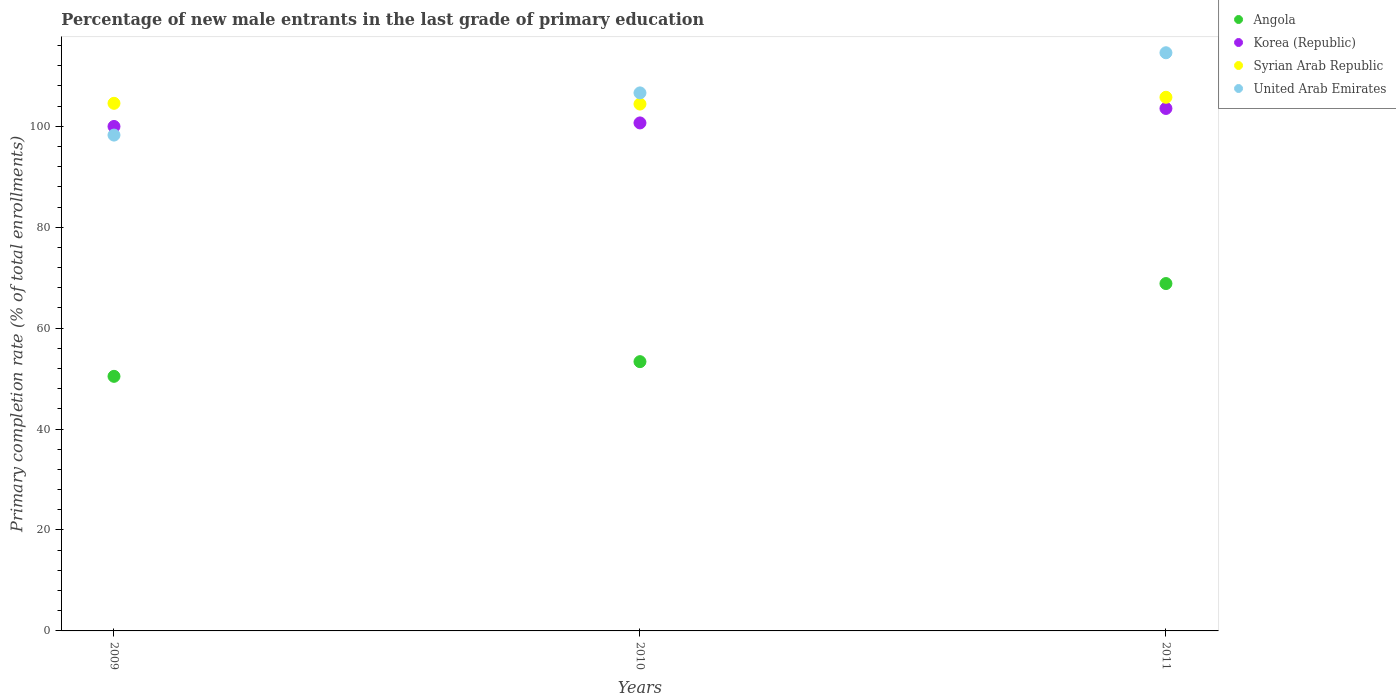How many different coloured dotlines are there?
Provide a succinct answer. 4. Is the number of dotlines equal to the number of legend labels?
Your answer should be very brief. Yes. What is the percentage of new male entrants in United Arab Emirates in 2009?
Your answer should be very brief. 98.25. Across all years, what is the maximum percentage of new male entrants in Korea (Republic)?
Your response must be concise. 103.53. Across all years, what is the minimum percentage of new male entrants in Korea (Republic)?
Provide a succinct answer. 99.96. In which year was the percentage of new male entrants in Angola maximum?
Give a very brief answer. 2011. What is the total percentage of new male entrants in United Arab Emirates in the graph?
Keep it short and to the point. 319.42. What is the difference between the percentage of new male entrants in Korea (Republic) in 2010 and that in 2011?
Keep it short and to the point. -2.87. What is the difference between the percentage of new male entrants in Korea (Republic) in 2010 and the percentage of new male entrants in United Arab Emirates in 2009?
Provide a short and direct response. 2.41. What is the average percentage of new male entrants in United Arab Emirates per year?
Your answer should be compact. 106.47. In the year 2011, what is the difference between the percentage of new male entrants in Korea (Republic) and percentage of new male entrants in Syrian Arab Republic?
Your response must be concise. -2.22. In how many years, is the percentage of new male entrants in Korea (Republic) greater than 100 %?
Offer a very short reply. 2. What is the ratio of the percentage of new male entrants in United Arab Emirates in 2009 to that in 2010?
Keep it short and to the point. 0.92. Is the percentage of new male entrants in Angola in 2010 less than that in 2011?
Your answer should be very brief. Yes. Is the difference between the percentage of new male entrants in Korea (Republic) in 2009 and 2010 greater than the difference between the percentage of new male entrants in Syrian Arab Republic in 2009 and 2010?
Make the answer very short. No. What is the difference between the highest and the second highest percentage of new male entrants in United Arab Emirates?
Ensure brevity in your answer.  7.95. What is the difference between the highest and the lowest percentage of new male entrants in Syrian Arab Republic?
Your answer should be very brief. 1.34. Is the sum of the percentage of new male entrants in Korea (Republic) in 2009 and 2010 greater than the maximum percentage of new male entrants in United Arab Emirates across all years?
Offer a very short reply. Yes. Does the percentage of new male entrants in Syrian Arab Republic monotonically increase over the years?
Offer a very short reply. No. Is the percentage of new male entrants in Angola strictly greater than the percentage of new male entrants in Syrian Arab Republic over the years?
Make the answer very short. No. How many dotlines are there?
Your response must be concise. 4. How many years are there in the graph?
Your answer should be very brief. 3. What is the difference between two consecutive major ticks on the Y-axis?
Ensure brevity in your answer.  20. Are the values on the major ticks of Y-axis written in scientific E-notation?
Make the answer very short. No. How are the legend labels stacked?
Offer a very short reply. Vertical. What is the title of the graph?
Keep it short and to the point. Percentage of new male entrants in the last grade of primary education. Does "United States" appear as one of the legend labels in the graph?
Your answer should be very brief. No. What is the label or title of the Y-axis?
Ensure brevity in your answer.  Primary completion rate (% of total enrollments). What is the Primary completion rate (% of total enrollments) of Angola in 2009?
Ensure brevity in your answer.  50.45. What is the Primary completion rate (% of total enrollments) in Korea (Republic) in 2009?
Your answer should be compact. 99.96. What is the Primary completion rate (% of total enrollments) of Syrian Arab Republic in 2009?
Make the answer very short. 104.54. What is the Primary completion rate (% of total enrollments) of United Arab Emirates in 2009?
Provide a succinct answer. 98.25. What is the Primary completion rate (% of total enrollments) in Angola in 2010?
Offer a very short reply. 53.36. What is the Primary completion rate (% of total enrollments) in Korea (Republic) in 2010?
Provide a short and direct response. 100.66. What is the Primary completion rate (% of total enrollments) in Syrian Arab Republic in 2010?
Keep it short and to the point. 104.4. What is the Primary completion rate (% of total enrollments) in United Arab Emirates in 2010?
Provide a short and direct response. 106.61. What is the Primary completion rate (% of total enrollments) of Angola in 2011?
Ensure brevity in your answer.  68.83. What is the Primary completion rate (% of total enrollments) in Korea (Republic) in 2011?
Make the answer very short. 103.53. What is the Primary completion rate (% of total enrollments) in Syrian Arab Republic in 2011?
Your answer should be compact. 105.74. What is the Primary completion rate (% of total enrollments) of United Arab Emirates in 2011?
Ensure brevity in your answer.  114.56. Across all years, what is the maximum Primary completion rate (% of total enrollments) in Angola?
Your answer should be very brief. 68.83. Across all years, what is the maximum Primary completion rate (% of total enrollments) in Korea (Republic)?
Offer a terse response. 103.53. Across all years, what is the maximum Primary completion rate (% of total enrollments) in Syrian Arab Republic?
Make the answer very short. 105.74. Across all years, what is the maximum Primary completion rate (% of total enrollments) of United Arab Emirates?
Make the answer very short. 114.56. Across all years, what is the minimum Primary completion rate (% of total enrollments) in Angola?
Your answer should be compact. 50.45. Across all years, what is the minimum Primary completion rate (% of total enrollments) in Korea (Republic)?
Your answer should be very brief. 99.96. Across all years, what is the minimum Primary completion rate (% of total enrollments) in Syrian Arab Republic?
Your answer should be very brief. 104.4. Across all years, what is the minimum Primary completion rate (% of total enrollments) in United Arab Emirates?
Make the answer very short. 98.25. What is the total Primary completion rate (% of total enrollments) in Angola in the graph?
Offer a very short reply. 172.63. What is the total Primary completion rate (% of total enrollments) in Korea (Republic) in the graph?
Your answer should be very brief. 304.14. What is the total Primary completion rate (% of total enrollments) in Syrian Arab Republic in the graph?
Your answer should be compact. 314.69. What is the total Primary completion rate (% of total enrollments) of United Arab Emirates in the graph?
Your answer should be very brief. 319.42. What is the difference between the Primary completion rate (% of total enrollments) of Angola in 2009 and that in 2010?
Provide a succinct answer. -2.91. What is the difference between the Primary completion rate (% of total enrollments) of Korea (Republic) in 2009 and that in 2010?
Provide a succinct answer. -0.7. What is the difference between the Primary completion rate (% of total enrollments) in Syrian Arab Republic in 2009 and that in 2010?
Make the answer very short. 0.14. What is the difference between the Primary completion rate (% of total enrollments) of United Arab Emirates in 2009 and that in 2010?
Your answer should be very brief. -8.36. What is the difference between the Primary completion rate (% of total enrollments) in Angola in 2009 and that in 2011?
Your answer should be compact. -18.39. What is the difference between the Primary completion rate (% of total enrollments) in Korea (Republic) in 2009 and that in 2011?
Your answer should be compact. -3.57. What is the difference between the Primary completion rate (% of total enrollments) of Syrian Arab Republic in 2009 and that in 2011?
Your answer should be compact. -1.2. What is the difference between the Primary completion rate (% of total enrollments) of United Arab Emirates in 2009 and that in 2011?
Ensure brevity in your answer.  -16.31. What is the difference between the Primary completion rate (% of total enrollments) of Angola in 2010 and that in 2011?
Ensure brevity in your answer.  -15.48. What is the difference between the Primary completion rate (% of total enrollments) of Korea (Republic) in 2010 and that in 2011?
Ensure brevity in your answer.  -2.87. What is the difference between the Primary completion rate (% of total enrollments) in Syrian Arab Republic in 2010 and that in 2011?
Offer a terse response. -1.34. What is the difference between the Primary completion rate (% of total enrollments) of United Arab Emirates in 2010 and that in 2011?
Offer a very short reply. -7.95. What is the difference between the Primary completion rate (% of total enrollments) in Angola in 2009 and the Primary completion rate (% of total enrollments) in Korea (Republic) in 2010?
Provide a short and direct response. -50.21. What is the difference between the Primary completion rate (% of total enrollments) in Angola in 2009 and the Primary completion rate (% of total enrollments) in Syrian Arab Republic in 2010?
Provide a short and direct response. -53.96. What is the difference between the Primary completion rate (% of total enrollments) of Angola in 2009 and the Primary completion rate (% of total enrollments) of United Arab Emirates in 2010?
Give a very brief answer. -56.16. What is the difference between the Primary completion rate (% of total enrollments) of Korea (Republic) in 2009 and the Primary completion rate (% of total enrollments) of Syrian Arab Republic in 2010?
Keep it short and to the point. -4.44. What is the difference between the Primary completion rate (% of total enrollments) of Korea (Republic) in 2009 and the Primary completion rate (% of total enrollments) of United Arab Emirates in 2010?
Ensure brevity in your answer.  -6.65. What is the difference between the Primary completion rate (% of total enrollments) in Syrian Arab Republic in 2009 and the Primary completion rate (% of total enrollments) in United Arab Emirates in 2010?
Keep it short and to the point. -2.07. What is the difference between the Primary completion rate (% of total enrollments) of Angola in 2009 and the Primary completion rate (% of total enrollments) of Korea (Republic) in 2011?
Your response must be concise. -53.08. What is the difference between the Primary completion rate (% of total enrollments) of Angola in 2009 and the Primary completion rate (% of total enrollments) of Syrian Arab Republic in 2011?
Keep it short and to the point. -55.3. What is the difference between the Primary completion rate (% of total enrollments) in Angola in 2009 and the Primary completion rate (% of total enrollments) in United Arab Emirates in 2011?
Keep it short and to the point. -64.12. What is the difference between the Primary completion rate (% of total enrollments) in Korea (Republic) in 2009 and the Primary completion rate (% of total enrollments) in Syrian Arab Republic in 2011?
Give a very brief answer. -5.78. What is the difference between the Primary completion rate (% of total enrollments) of Korea (Republic) in 2009 and the Primary completion rate (% of total enrollments) of United Arab Emirates in 2011?
Your answer should be compact. -14.61. What is the difference between the Primary completion rate (% of total enrollments) in Syrian Arab Republic in 2009 and the Primary completion rate (% of total enrollments) in United Arab Emirates in 2011?
Provide a succinct answer. -10.02. What is the difference between the Primary completion rate (% of total enrollments) of Angola in 2010 and the Primary completion rate (% of total enrollments) of Korea (Republic) in 2011?
Provide a short and direct response. -50.17. What is the difference between the Primary completion rate (% of total enrollments) of Angola in 2010 and the Primary completion rate (% of total enrollments) of Syrian Arab Republic in 2011?
Offer a terse response. -52.39. What is the difference between the Primary completion rate (% of total enrollments) in Angola in 2010 and the Primary completion rate (% of total enrollments) in United Arab Emirates in 2011?
Provide a short and direct response. -61.21. What is the difference between the Primary completion rate (% of total enrollments) in Korea (Republic) in 2010 and the Primary completion rate (% of total enrollments) in Syrian Arab Republic in 2011?
Your response must be concise. -5.08. What is the difference between the Primary completion rate (% of total enrollments) of Korea (Republic) in 2010 and the Primary completion rate (% of total enrollments) of United Arab Emirates in 2011?
Ensure brevity in your answer.  -13.9. What is the difference between the Primary completion rate (% of total enrollments) of Syrian Arab Republic in 2010 and the Primary completion rate (% of total enrollments) of United Arab Emirates in 2011?
Give a very brief answer. -10.16. What is the average Primary completion rate (% of total enrollments) of Angola per year?
Give a very brief answer. 57.54. What is the average Primary completion rate (% of total enrollments) in Korea (Republic) per year?
Give a very brief answer. 101.38. What is the average Primary completion rate (% of total enrollments) in Syrian Arab Republic per year?
Your answer should be compact. 104.9. What is the average Primary completion rate (% of total enrollments) of United Arab Emirates per year?
Offer a terse response. 106.47. In the year 2009, what is the difference between the Primary completion rate (% of total enrollments) in Angola and Primary completion rate (% of total enrollments) in Korea (Republic)?
Offer a very short reply. -49.51. In the year 2009, what is the difference between the Primary completion rate (% of total enrollments) of Angola and Primary completion rate (% of total enrollments) of Syrian Arab Republic?
Your answer should be compact. -54.1. In the year 2009, what is the difference between the Primary completion rate (% of total enrollments) in Angola and Primary completion rate (% of total enrollments) in United Arab Emirates?
Ensure brevity in your answer.  -47.8. In the year 2009, what is the difference between the Primary completion rate (% of total enrollments) of Korea (Republic) and Primary completion rate (% of total enrollments) of Syrian Arab Republic?
Your response must be concise. -4.59. In the year 2009, what is the difference between the Primary completion rate (% of total enrollments) of Korea (Republic) and Primary completion rate (% of total enrollments) of United Arab Emirates?
Give a very brief answer. 1.71. In the year 2009, what is the difference between the Primary completion rate (% of total enrollments) of Syrian Arab Republic and Primary completion rate (% of total enrollments) of United Arab Emirates?
Your response must be concise. 6.29. In the year 2010, what is the difference between the Primary completion rate (% of total enrollments) of Angola and Primary completion rate (% of total enrollments) of Korea (Republic)?
Your answer should be compact. -47.3. In the year 2010, what is the difference between the Primary completion rate (% of total enrollments) in Angola and Primary completion rate (% of total enrollments) in Syrian Arab Republic?
Your answer should be compact. -51.05. In the year 2010, what is the difference between the Primary completion rate (% of total enrollments) of Angola and Primary completion rate (% of total enrollments) of United Arab Emirates?
Your answer should be very brief. -53.25. In the year 2010, what is the difference between the Primary completion rate (% of total enrollments) in Korea (Republic) and Primary completion rate (% of total enrollments) in Syrian Arab Republic?
Provide a short and direct response. -3.74. In the year 2010, what is the difference between the Primary completion rate (% of total enrollments) in Korea (Republic) and Primary completion rate (% of total enrollments) in United Arab Emirates?
Offer a very short reply. -5.95. In the year 2010, what is the difference between the Primary completion rate (% of total enrollments) in Syrian Arab Republic and Primary completion rate (% of total enrollments) in United Arab Emirates?
Your answer should be very brief. -2.21. In the year 2011, what is the difference between the Primary completion rate (% of total enrollments) in Angola and Primary completion rate (% of total enrollments) in Korea (Republic)?
Make the answer very short. -34.7. In the year 2011, what is the difference between the Primary completion rate (% of total enrollments) of Angola and Primary completion rate (% of total enrollments) of Syrian Arab Republic?
Your response must be concise. -36.91. In the year 2011, what is the difference between the Primary completion rate (% of total enrollments) in Angola and Primary completion rate (% of total enrollments) in United Arab Emirates?
Provide a succinct answer. -45.73. In the year 2011, what is the difference between the Primary completion rate (% of total enrollments) in Korea (Republic) and Primary completion rate (% of total enrollments) in Syrian Arab Republic?
Ensure brevity in your answer.  -2.22. In the year 2011, what is the difference between the Primary completion rate (% of total enrollments) of Korea (Republic) and Primary completion rate (% of total enrollments) of United Arab Emirates?
Offer a very short reply. -11.04. In the year 2011, what is the difference between the Primary completion rate (% of total enrollments) in Syrian Arab Republic and Primary completion rate (% of total enrollments) in United Arab Emirates?
Your answer should be very brief. -8.82. What is the ratio of the Primary completion rate (% of total enrollments) of Angola in 2009 to that in 2010?
Offer a very short reply. 0.95. What is the ratio of the Primary completion rate (% of total enrollments) in United Arab Emirates in 2009 to that in 2010?
Make the answer very short. 0.92. What is the ratio of the Primary completion rate (% of total enrollments) of Angola in 2009 to that in 2011?
Provide a succinct answer. 0.73. What is the ratio of the Primary completion rate (% of total enrollments) in Korea (Republic) in 2009 to that in 2011?
Offer a very short reply. 0.97. What is the ratio of the Primary completion rate (% of total enrollments) of Syrian Arab Republic in 2009 to that in 2011?
Ensure brevity in your answer.  0.99. What is the ratio of the Primary completion rate (% of total enrollments) in United Arab Emirates in 2009 to that in 2011?
Ensure brevity in your answer.  0.86. What is the ratio of the Primary completion rate (% of total enrollments) of Angola in 2010 to that in 2011?
Make the answer very short. 0.78. What is the ratio of the Primary completion rate (% of total enrollments) of Korea (Republic) in 2010 to that in 2011?
Keep it short and to the point. 0.97. What is the ratio of the Primary completion rate (% of total enrollments) in Syrian Arab Republic in 2010 to that in 2011?
Your answer should be very brief. 0.99. What is the ratio of the Primary completion rate (% of total enrollments) of United Arab Emirates in 2010 to that in 2011?
Your answer should be very brief. 0.93. What is the difference between the highest and the second highest Primary completion rate (% of total enrollments) of Angola?
Your response must be concise. 15.48. What is the difference between the highest and the second highest Primary completion rate (% of total enrollments) in Korea (Republic)?
Your answer should be compact. 2.87. What is the difference between the highest and the second highest Primary completion rate (% of total enrollments) in Syrian Arab Republic?
Give a very brief answer. 1.2. What is the difference between the highest and the second highest Primary completion rate (% of total enrollments) in United Arab Emirates?
Your answer should be compact. 7.95. What is the difference between the highest and the lowest Primary completion rate (% of total enrollments) of Angola?
Provide a succinct answer. 18.39. What is the difference between the highest and the lowest Primary completion rate (% of total enrollments) of Korea (Republic)?
Provide a succinct answer. 3.57. What is the difference between the highest and the lowest Primary completion rate (% of total enrollments) of Syrian Arab Republic?
Keep it short and to the point. 1.34. What is the difference between the highest and the lowest Primary completion rate (% of total enrollments) in United Arab Emirates?
Provide a succinct answer. 16.31. 